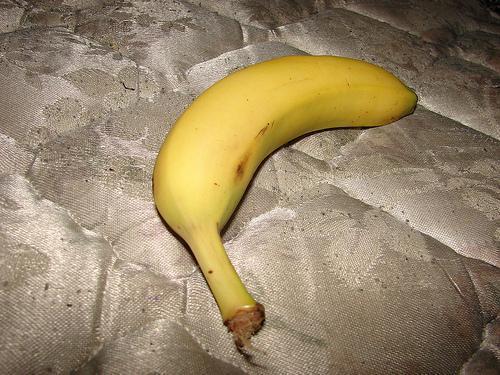How many bananas?
Give a very brief answer. 1. 